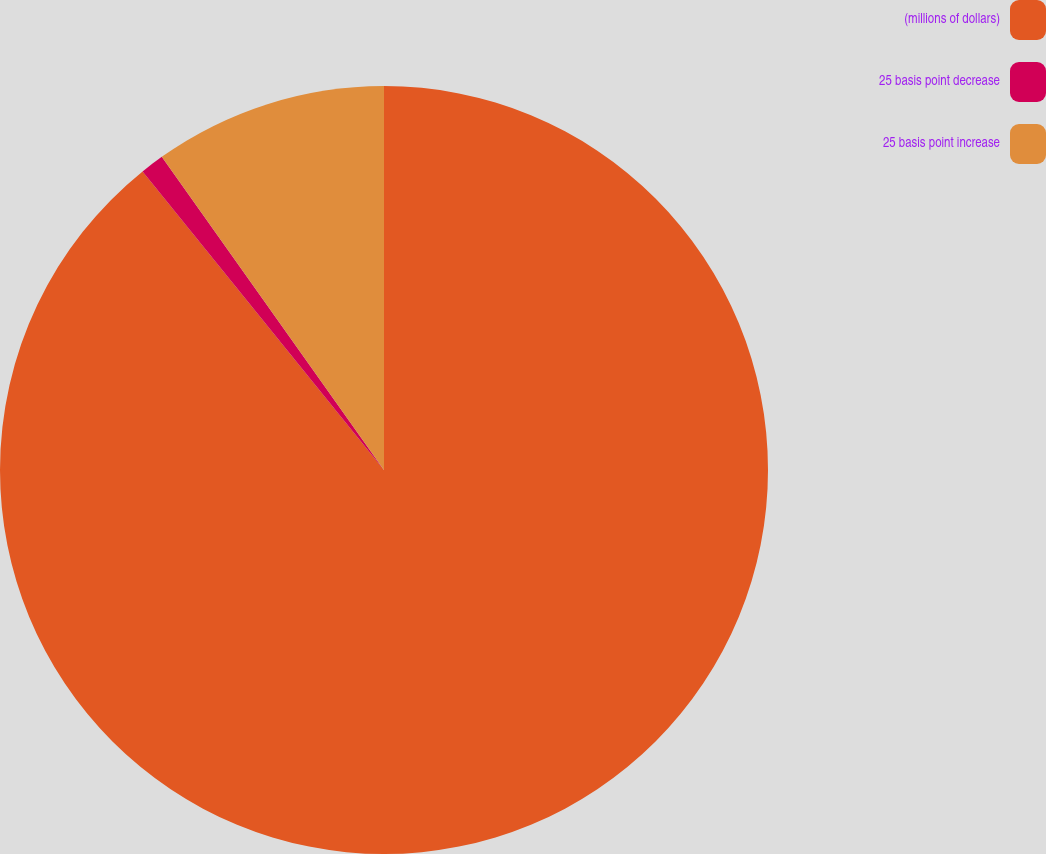Convert chart. <chart><loc_0><loc_0><loc_500><loc_500><pie_chart><fcel>(millions of dollars)<fcel>25 basis point decrease<fcel>25 basis point increase<nl><fcel>89.17%<fcel>1.0%<fcel>9.82%<nl></chart> 